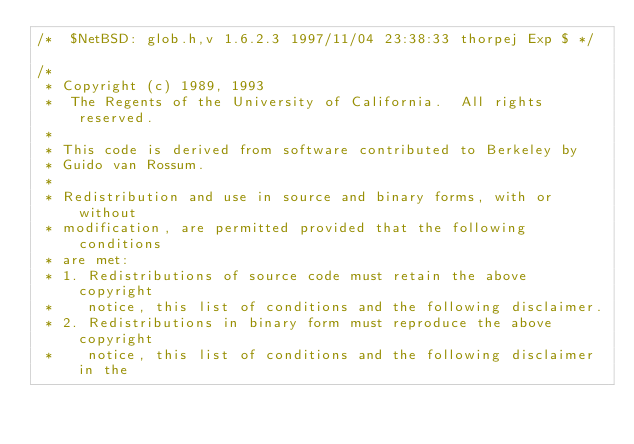<code> <loc_0><loc_0><loc_500><loc_500><_C_>/*	$NetBSD: glob.h,v 1.6.2.3 1997/11/04 23:38:33 thorpej Exp $	*/

/*
 * Copyright (c) 1989, 1993
 *	The Regents of the University of California.  All rights reserved.
 *
 * This code is derived from software contributed to Berkeley by
 * Guido van Rossum.
 *
 * Redistribution and use in source and binary forms, with or without
 * modification, are permitted provided that the following conditions
 * are met:
 * 1. Redistributions of source code must retain the above copyright
 *    notice, this list of conditions and the following disclaimer.
 * 2. Redistributions in binary form must reproduce the above copyright
 *    notice, this list of conditions and the following disclaimer in the</code> 